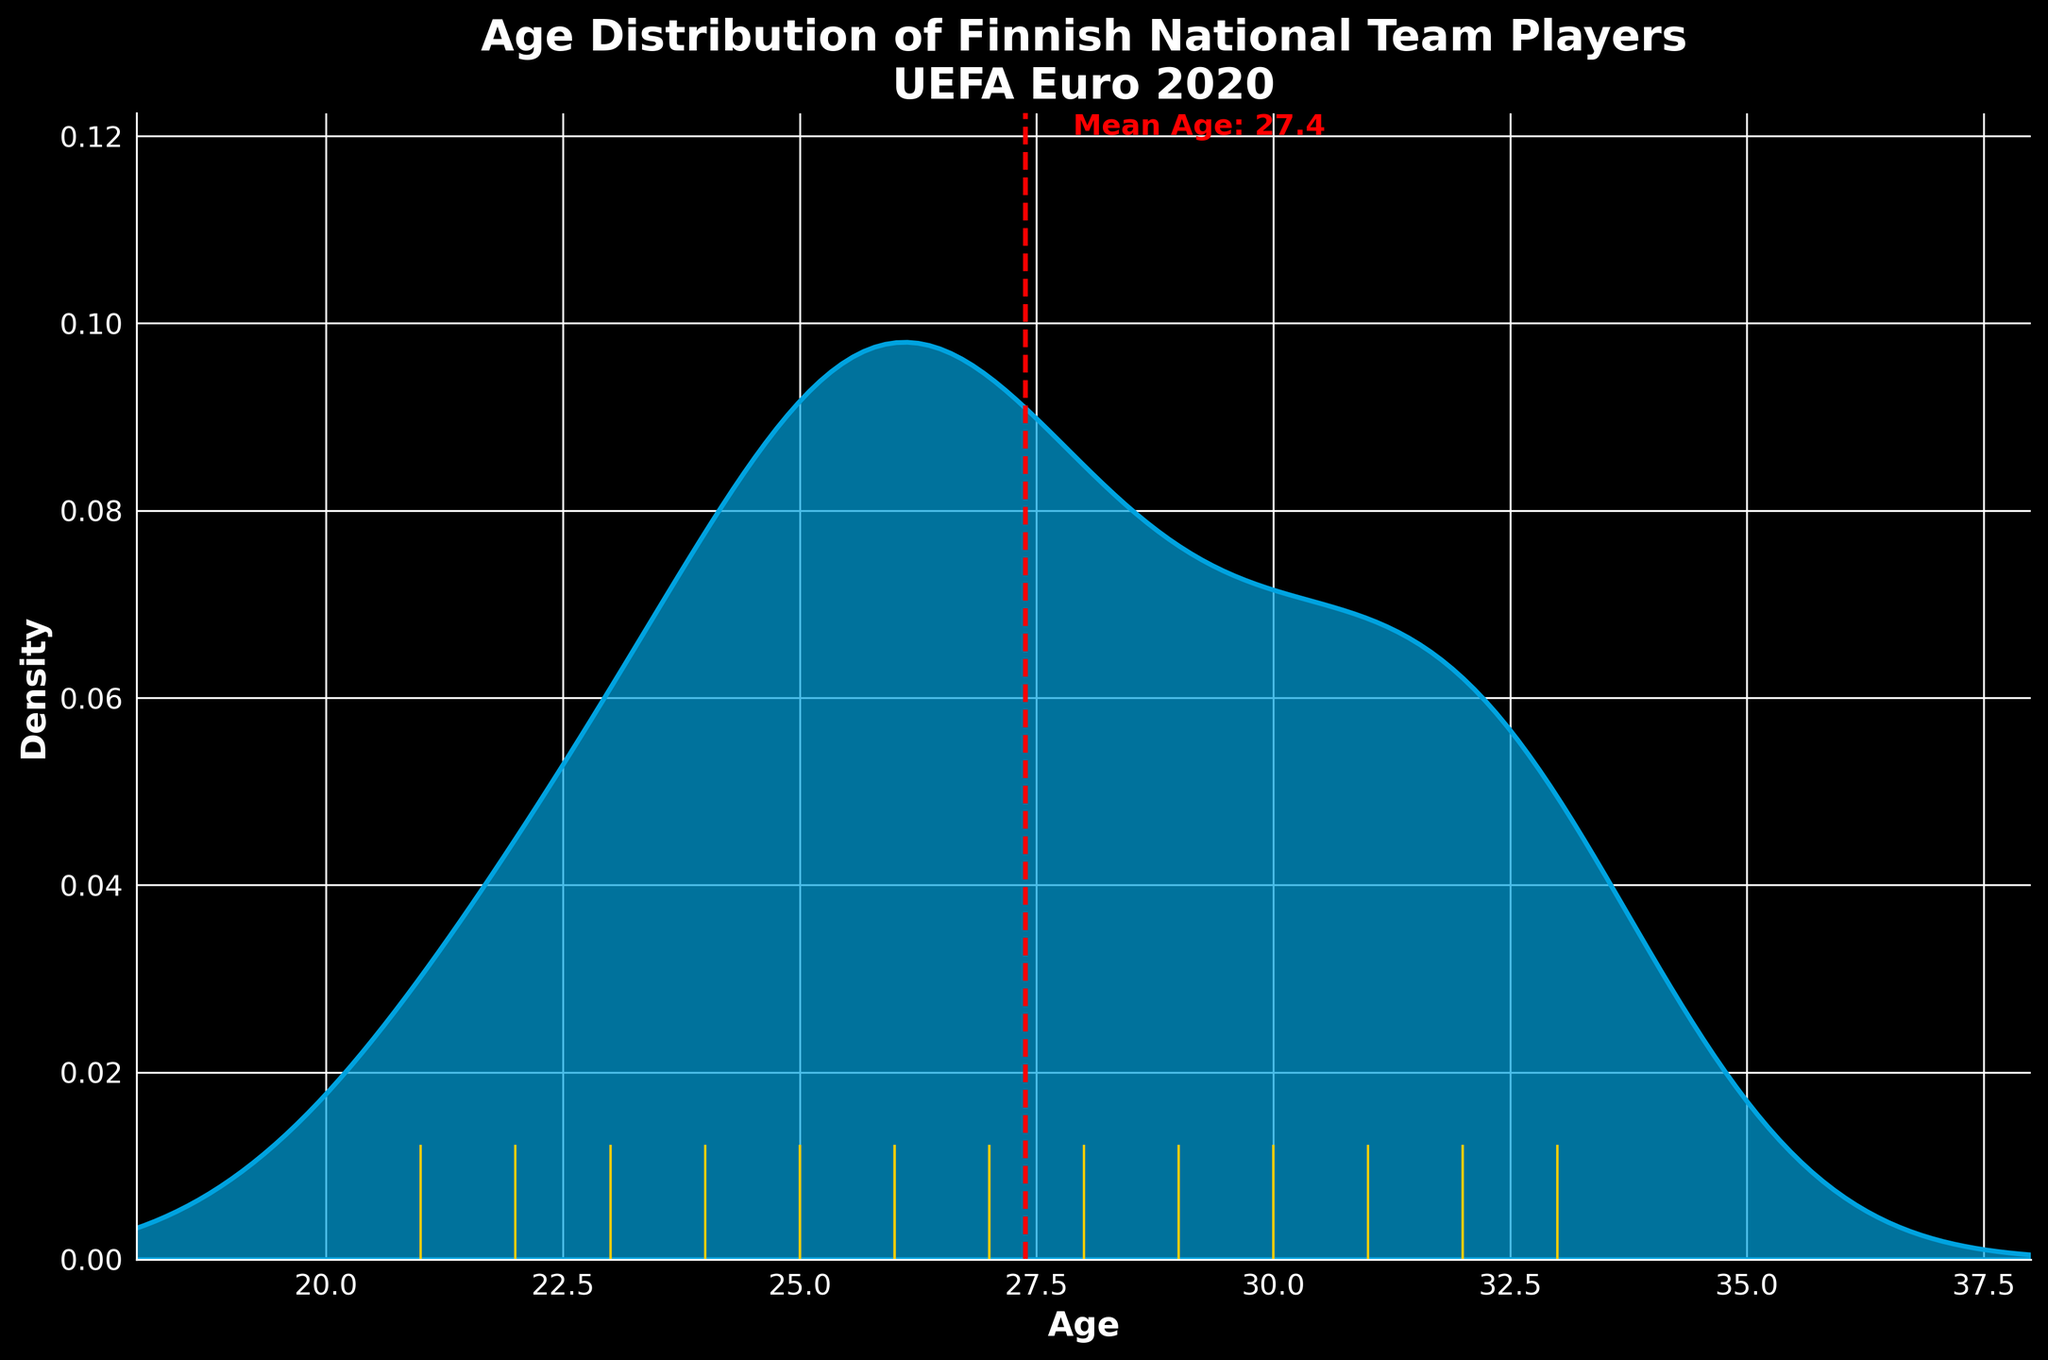What is the title of the plot? The title is written at the top of the plot. It reads: "Age Distribution of Finnish National Team Players UEFA Euro 2020".
Answer: Age Distribution of Finnish National Team Players UEFA Euro 2020 What does the x-axis represent? The label on the x-axis clearly indicates that it represents the ages of the players.
Answer: Age What is the range of ages shown on the x-axis? The x-axis spans from 18 to 38, as indicated by the values at the ends of the axis.
Answer: 18 to 38 What is the mean age of the players? A dashed vertical line is marked at the mean age on the x-axis, and the text next to it reads "Mean Age: 27.7".
Answer: 27.7 How is the mean age visually marked on the plot? The mean age is marked by a red dashed vertical line with text to the right indicating the value.
Answer: Red dashed line Which age appears most frequently in the plot? The highest peak in the density plot indicates the mode, which is around age 26.
Answer: 26 How many age points are marked on the rug plot? By counting the yellow lines at the bottom of the plot, which represent individual data points, there are 26 players' ages marked.
Answer: 26 Is the age distribution skewed towards younger or older players? The plot shows a higher density of younger players with a gradual decrease towards older ages, indicating it's skewed towards younger players.
Answer: Younger players Which age is at the first peak, and which age is at the second peak? The first noticeable peak occurs around age 22-23, and the second peak is around age 26.
Answer: First peak: 22-23, Second peak: 26 